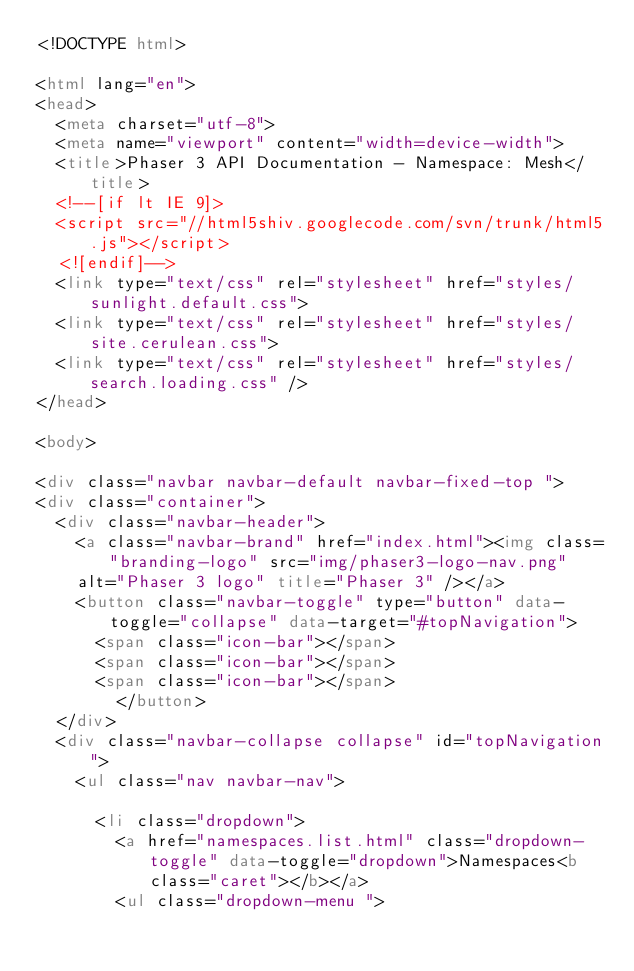<code> <loc_0><loc_0><loc_500><loc_500><_HTML_><!DOCTYPE html>

<html lang="en">
<head>
	<meta charset="utf-8">
	<meta name="viewport" content="width=device-width">
	<title>Phaser 3 API Documentation - Namespace: Mesh</title>
	<!--[if lt IE 9]>
	<script src="//html5shiv.googlecode.com/svn/trunk/html5.js"></script>
	<![endif]-->
	<link type="text/css" rel="stylesheet" href="styles/sunlight.default.css">
	<link type="text/css" rel="stylesheet" href="styles/site.cerulean.css">
	<link type="text/css" rel="stylesheet" href="styles/search.loading.css" />
</head>

<body>

<div class="navbar navbar-default navbar-fixed-top ">
<div class="container">
	<div class="navbar-header">
		<a class="navbar-brand" href="index.html"><img class="branding-logo" src="img/phaser3-logo-nav.png"
		alt="Phaser 3 logo" title="Phaser 3" /></a>
		<button class="navbar-toggle" type="button" data-toggle="collapse" data-target="#topNavigation">
			<span class="icon-bar"></span>
			<span class="icon-bar"></span>
			<span class="icon-bar"></span>
        </button>
	</div>
	<div class="navbar-collapse collapse" id="topNavigation">
		<ul class="nav navbar-nav">
			
			<li class="dropdown">
				<a href="namespaces.list.html" class="dropdown-toggle" data-toggle="dropdown">Namespaces<b class="caret"></b></a>
				<ul class="dropdown-menu "></code> 